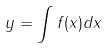Convert formula to latex. <formula><loc_0><loc_0><loc_500><loc_500>y = \int f ( x ) d x</formula> 